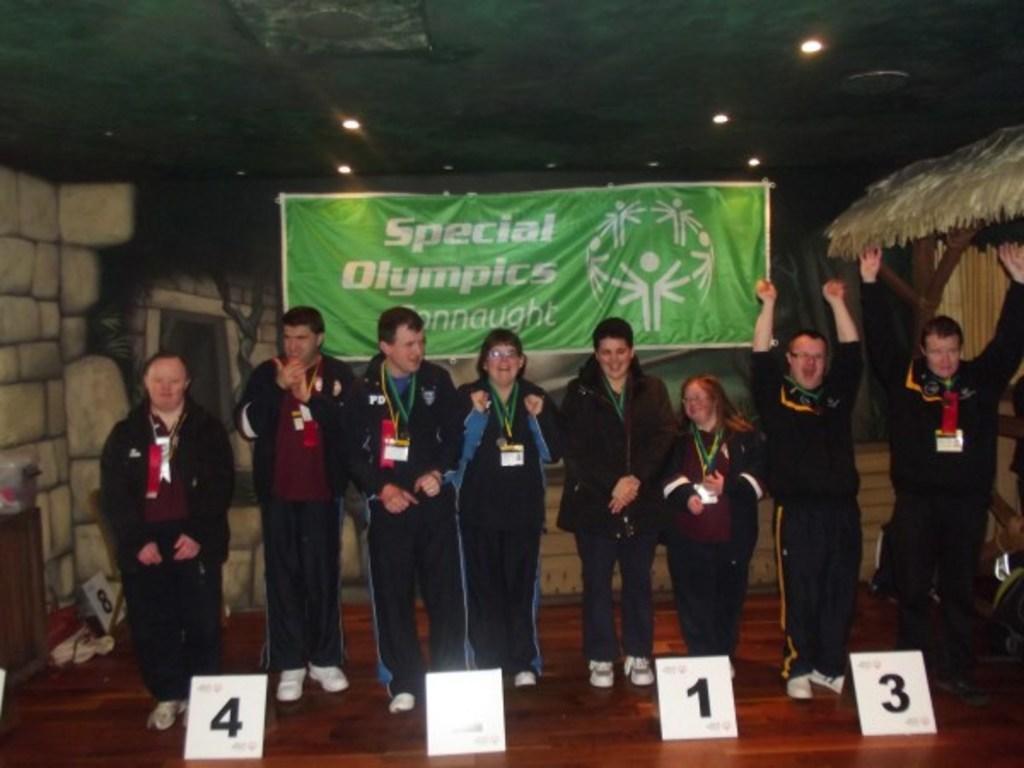Could you give a brief overview of what you see in this image? In this image there are people standing wearing id tags in front of them there are board on that boards there are numbers, in the background there is a wall, on that wall there is a banner, on that banner is text and a log, at the top there is a ceiling and lights. 